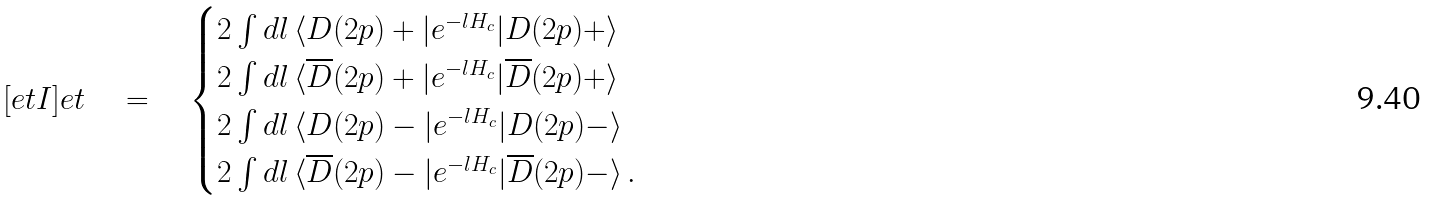Convert formula to latex. <formula><loc_0><loc_0><loc_500><loc_500>[ e t I ] e t \quad = \quad \begin{cases} 2 \int d l \, \langle D ( 2 p ) + | e ^ { - l H _ { c } } | D ( 2 p ) + \rangle \\ 2 \int d l \, \langle \overline { D } ( 2 p ) + | e ^ { - l H _ { c } } | \overline { D } ( 2 p ) + \rangle \\ 2 \int d l \, \langle D ( 2 p ) - | e ^ { - l H _ { c } } | D ( 2 p ) - \rangle \\ 2 \int d l \, \langle \overline { D } ( 2 p ) - | e ^ { - l H _ { c } } | \overline { D } ( 2 p ) - \rangle \, . \end{cases}</formula> 